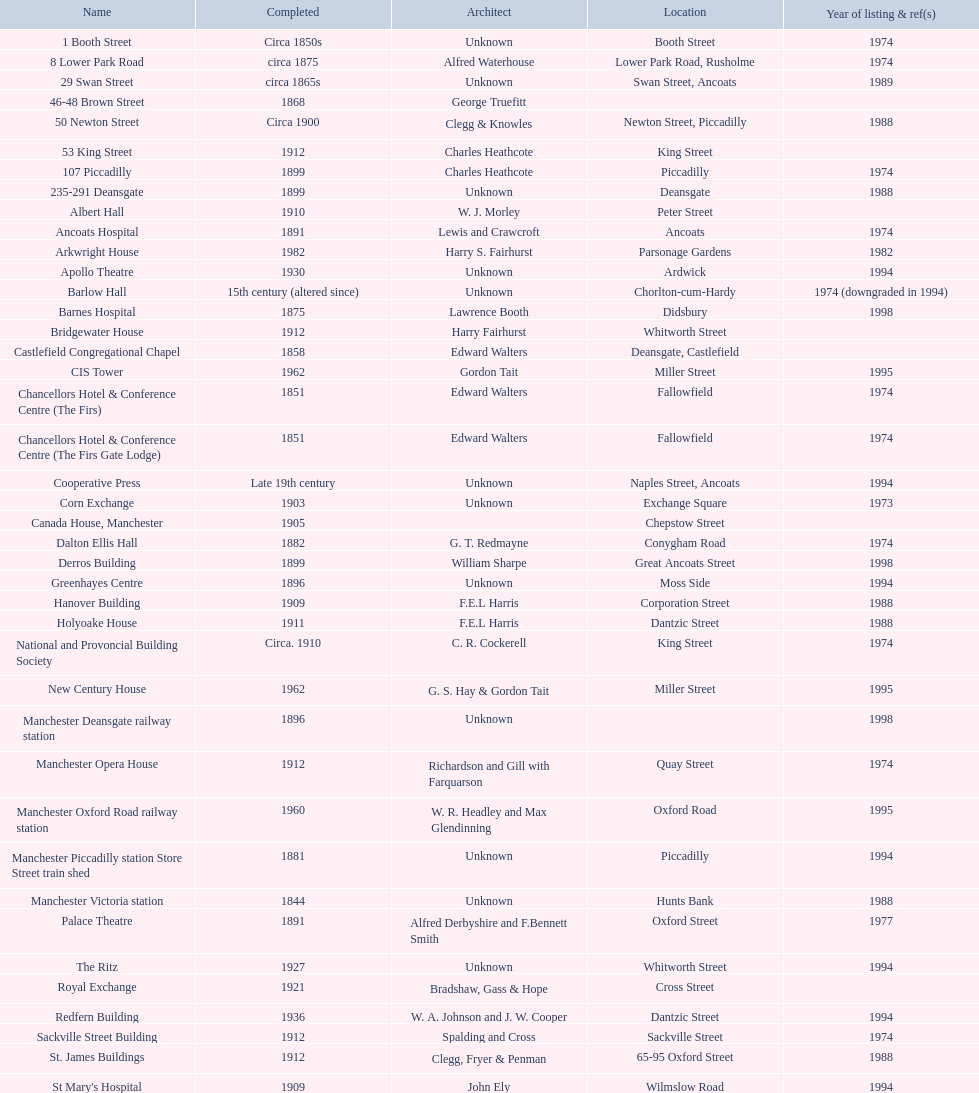How many edifices do not have a displayed image? 11. 